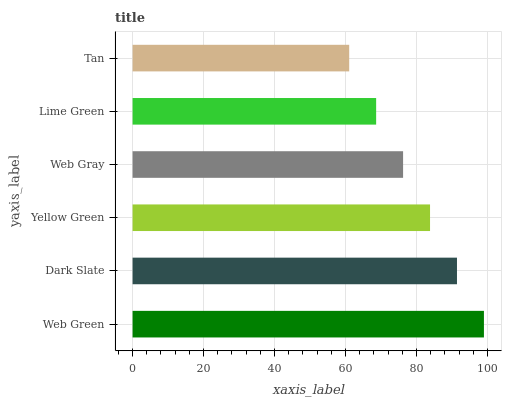Is Tan the minimum?
Answer yes or no. Yes. Is Web Green the maximum?
Answer yes or no. Yes. Is Dark Slate the minimum?
Answer yes or no. No. Is Dark Slate the maximum?
Answer yes or no. No. Is Web Green greater than Dark Slate?
Answer yes or no. Yes. Is Dark Slate less than Web Green?
Answer yes or no. Yes. Is Dark Slate greater than Web Green?
Answer yes or no. No. Is Web Green less than Dark Slate?
Answer yes or no. No. Is Yellow Green the high median?
Answer yes or no. Yes. Is Web Gray the low median?
Answer yes or no. Yes. Is Web Gray the high median?
Answer yes or no. No. Is Web Green the low median?
Answer yes or no. No. 